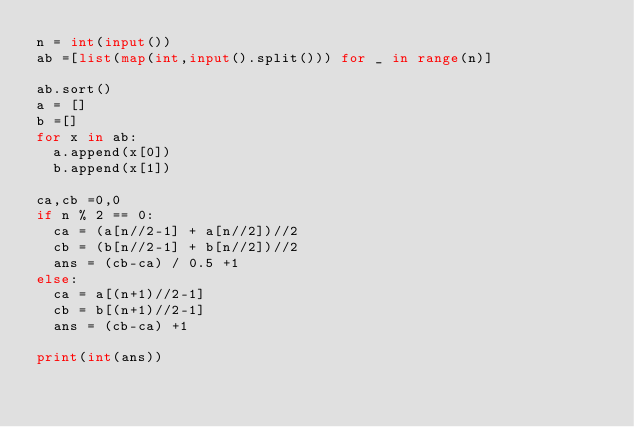<code> <loc_0><loc_0><loc_500><loc_500><_Python_>n = int(input())
ab =[list(map(int,input().split())) for _ in range(n)]

ab.sort()
a = []
b =[]
for x in ab:
  a.append(x[0])
  b.append(x[1])

ca,cb =0,0
if n % 2 == 0:
  ca = (a[n//2-1] + a[n//2])//2
  cb = (b[n//2-1] + b[n//2])//2
  ans = (cb-ca) / 0.5 +1
else:
  ca = a[(n+1)//2-1]
  cb = b[(n+1)//2-1]
  ans = (cb-ca) +1

print(int(ans))</code> 